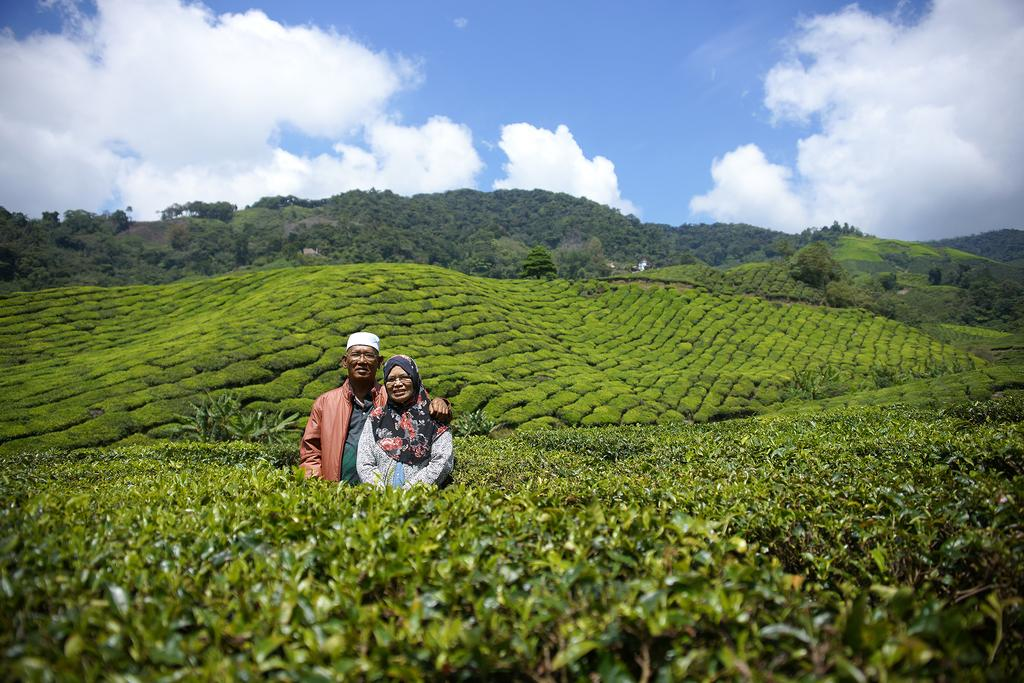Who can be seen in the image? There is a couple in the image. What is the setting of the image? The couple is standing among plants, and there is a greenery ground behind them. What can be seen in the background of the image? There are trees in the background of the image, and the sky is visible with some clouds. How many sheep are grazing on the clover in the image? There are no sheep or clover present in the image. What mathematical operation is being performed by the couple in the image? There is no indication of any mathematical operation being performed by the couple in the image. 